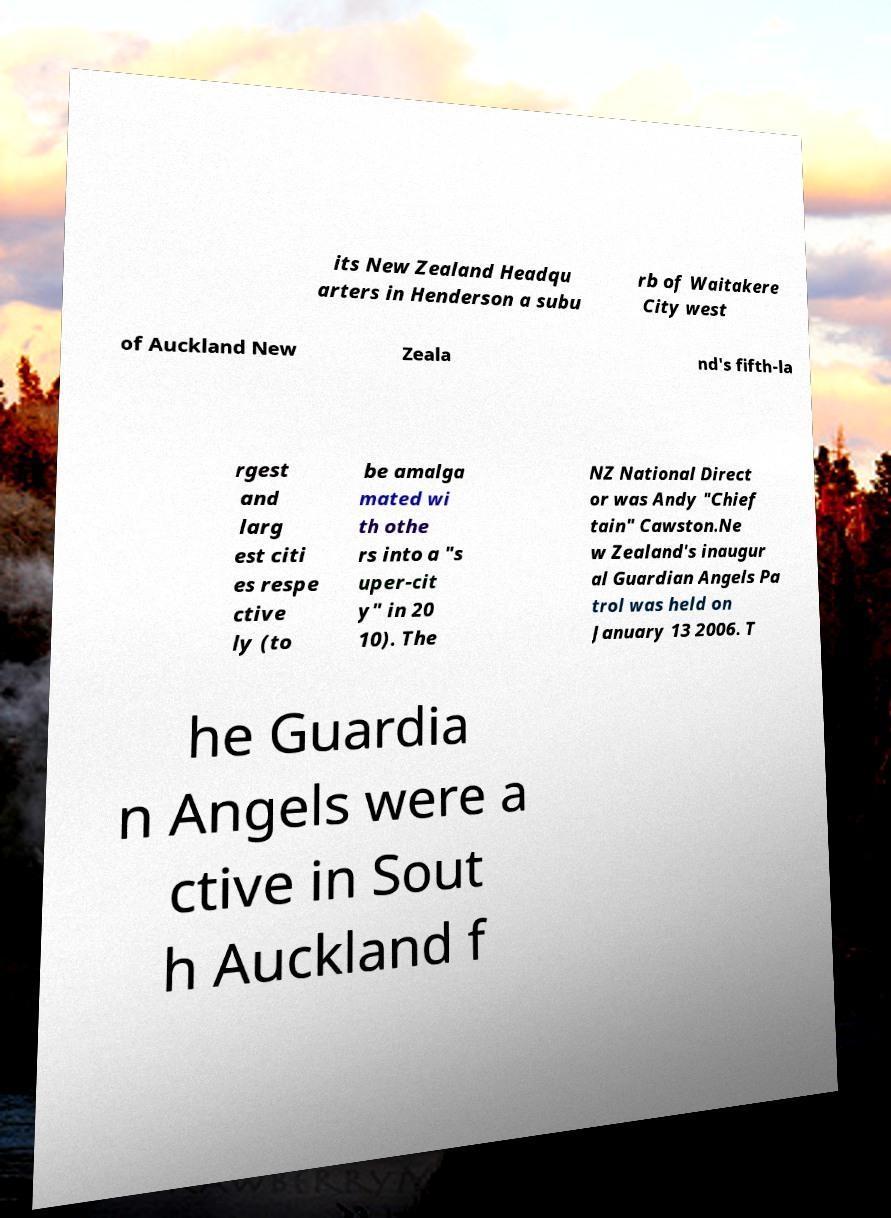There's text embedded in this image that I need extracted. Can you transcribe it verbatim? its New Zealand Headqu arters in Henderson a subu rb of Waitakere City west of Auckland New Zeala nd's fifth-la rgest and larg est citi es respe ctive ly (to be amalga mated wi th othe rs into a "s uper-cit y" in 20 10). The NZ National Direct or was Andy "Chief tain" Cawston.Ne w Zealand's inaugur al Guardian Angels Pa trol was held on January 13 2006. T he Guardia n Angels were a ctive in Sout h Auckland f 